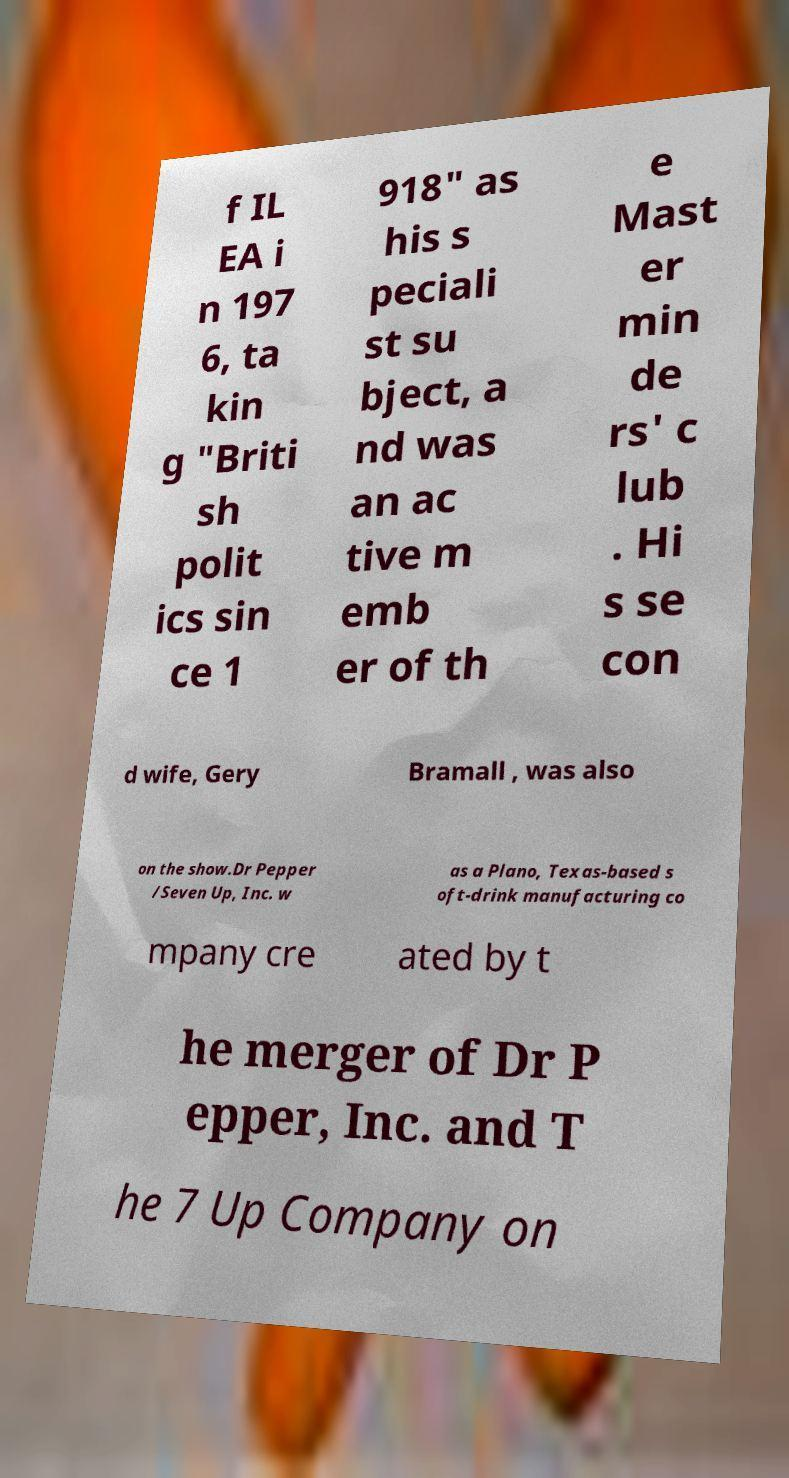Please read and relay the text visible in this image. What does it say? f IL EA i n 197 6, ta kin g "Briti sh polit ics sin ce 1 918" as his s peciali st su bject, a nd was an ac tive m emb er of th e Mast er min de rs' c lub . Hi s se con d wife, Gery Bramall , was also on the show.Dr Pepper /Seven Up, Inc. w as a Plano, Texas-based s oft-drink manufacturing co mpany cre ated by t he merger of Dr P epper, Inc. and T he 7 Up Company on 